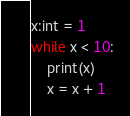Convert code to text. <code><loc_0><loc_0><loc_500><loc_500><_Python_>x:int = 1
while x < 10:
    print(x)
    x = x + 1
</code> 